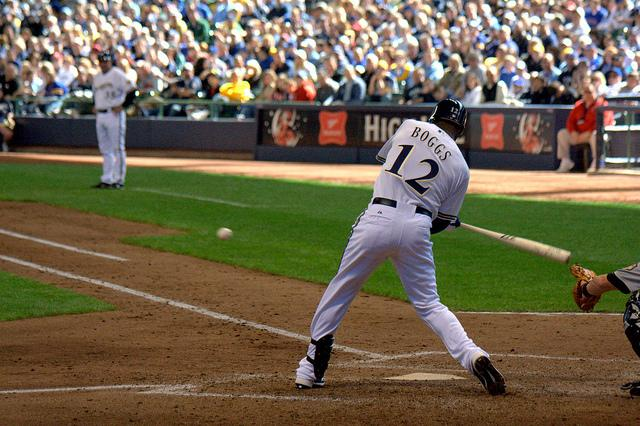Why cricketers wear white? uniform 